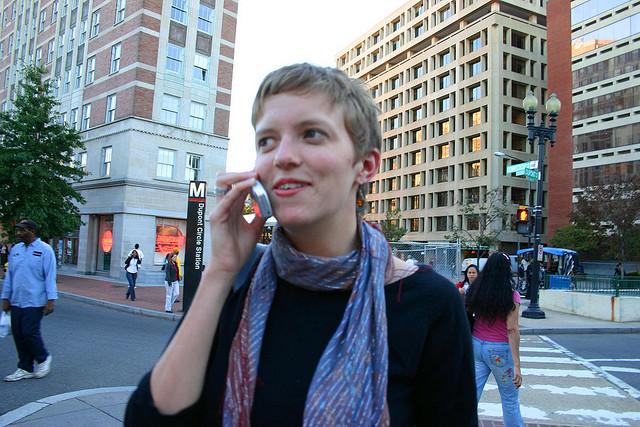Is she talking on a cell phone?
Short answer required. Yes. Is there a subway in this city?
Be succinct. Yes. Is the girl standing inside or outside?
Concise answer only. Outside. 